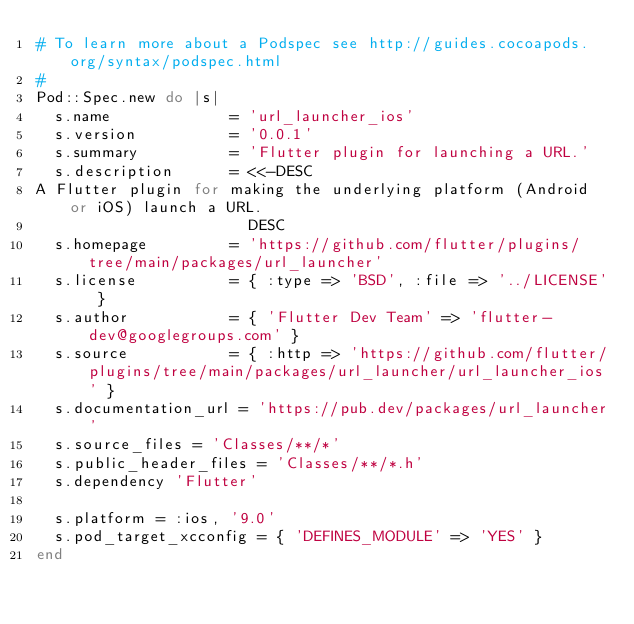<code> <loc_0><loc_0><loc_500><loc_500><_Ruby_># To learn more about a Podspec see http://guides.cocoapods.org/syntax/podspec.html
#
Pod::Spec.new do |s|
  s.name             = 'url_launcher_ios'
  s.version          = '0.0.1'
  s.summary          = 'Flutter plugin for launching a URL.'
  s.description      = <<-DESC
A Flutter plugin for making the underlying platform (Android or iOS) launch a URL.
                       DESC
  s.homepage         = 'https://github.com/flutter/plugins/tree/main/packages/url_launcher'
  s.license          = { :type => 'BSD', :file => '../LICENSE' }
  s.author           = { 'Flutter Dev Team' => 'flutter-dev@googlegroups.com' }
  s.source           = { :http => 'https://github.com/flutter/plugins/tree/main/packages/url_launcher/url_launcher_ios' }
  s.documentation_url = 'https://pub.dev/packages/url_launcher'
  s.source_files = 'Classes/**/*'
  s.public_header_files = 'Classes/**/*.h'
  s.dependency 'Flutter'

  s.platform = :ios, '9.0'
  s.pod_target_xcconfig = { 'DEFINES_MODULE' => 'YES' }
end
</code> 